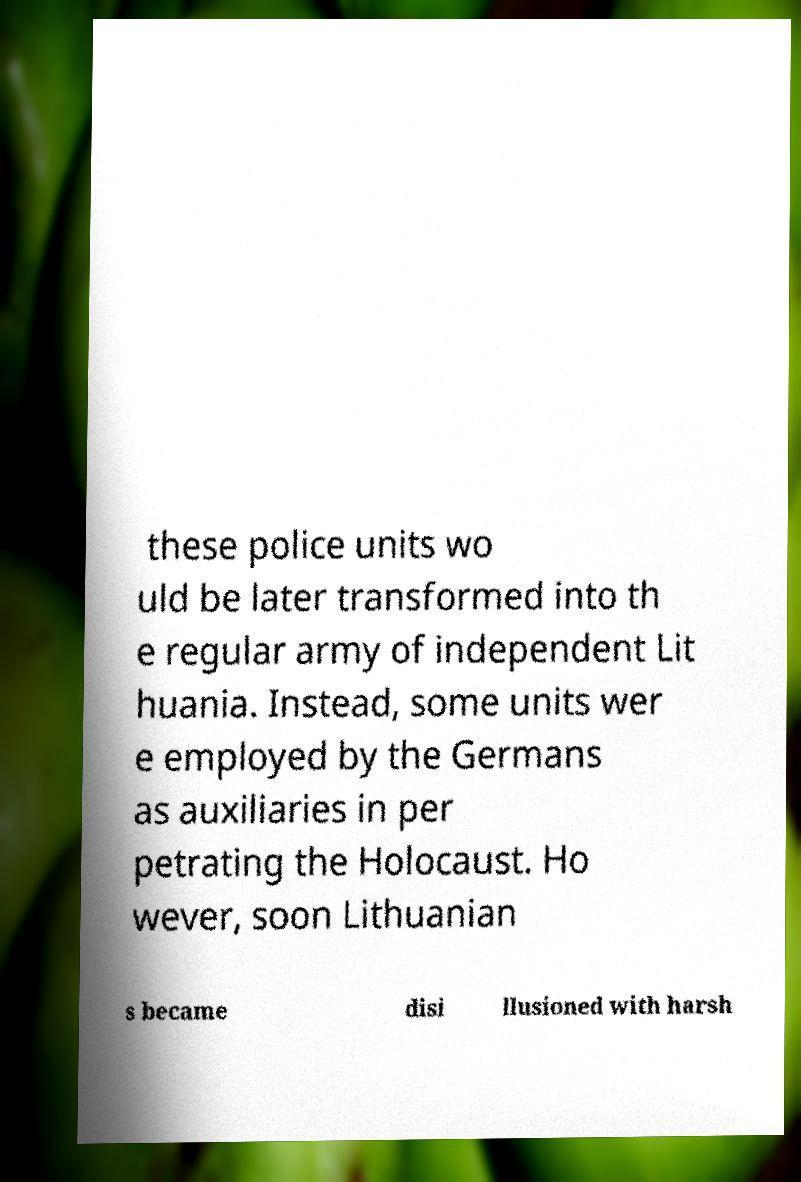Could you assist in decoding the text presented in this image and type it out clearly? these police units wo uld be later transformed into th e regular army of independent Lit huania. Instead, some units wer e employed by the Germans as auxiliaries in per petrating the Holocaust. Ho wever, soon Lithuanian s became disi llusioned with harsh 